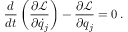<formula> <loc_0><loc_0><loc_500><loc_500>{ \frac { d } { d t } } \left ( { \frac { \partial { \mathcal { L } } } { \partial { \dot { q } } _ { j } } } \right ) - { \frac { \partial { \mathcal { L } } } { \partial q _ { j } } } = 0 \, .</formula> 